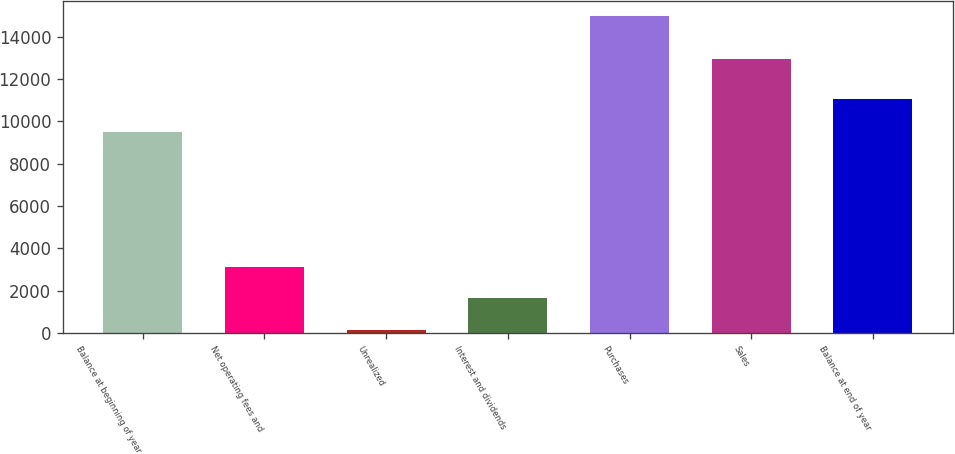Convert chart to OTSL. <chart><loc_0><loc_0><loc_500><loc_500><bar_chart><fcel>Balance at beginning of year<fcel>Net operating fees and<fcel>Unrealized<fcel>Interest and dividends<fcel>Purchases<fcel>Sales<fcel>Balance at end of year<nl><fcel>9484<fcel>3115.6<fcel>151<fcel>1633.3<fcel>14974<fcel>12976<fcel>11082<nl></chart> 